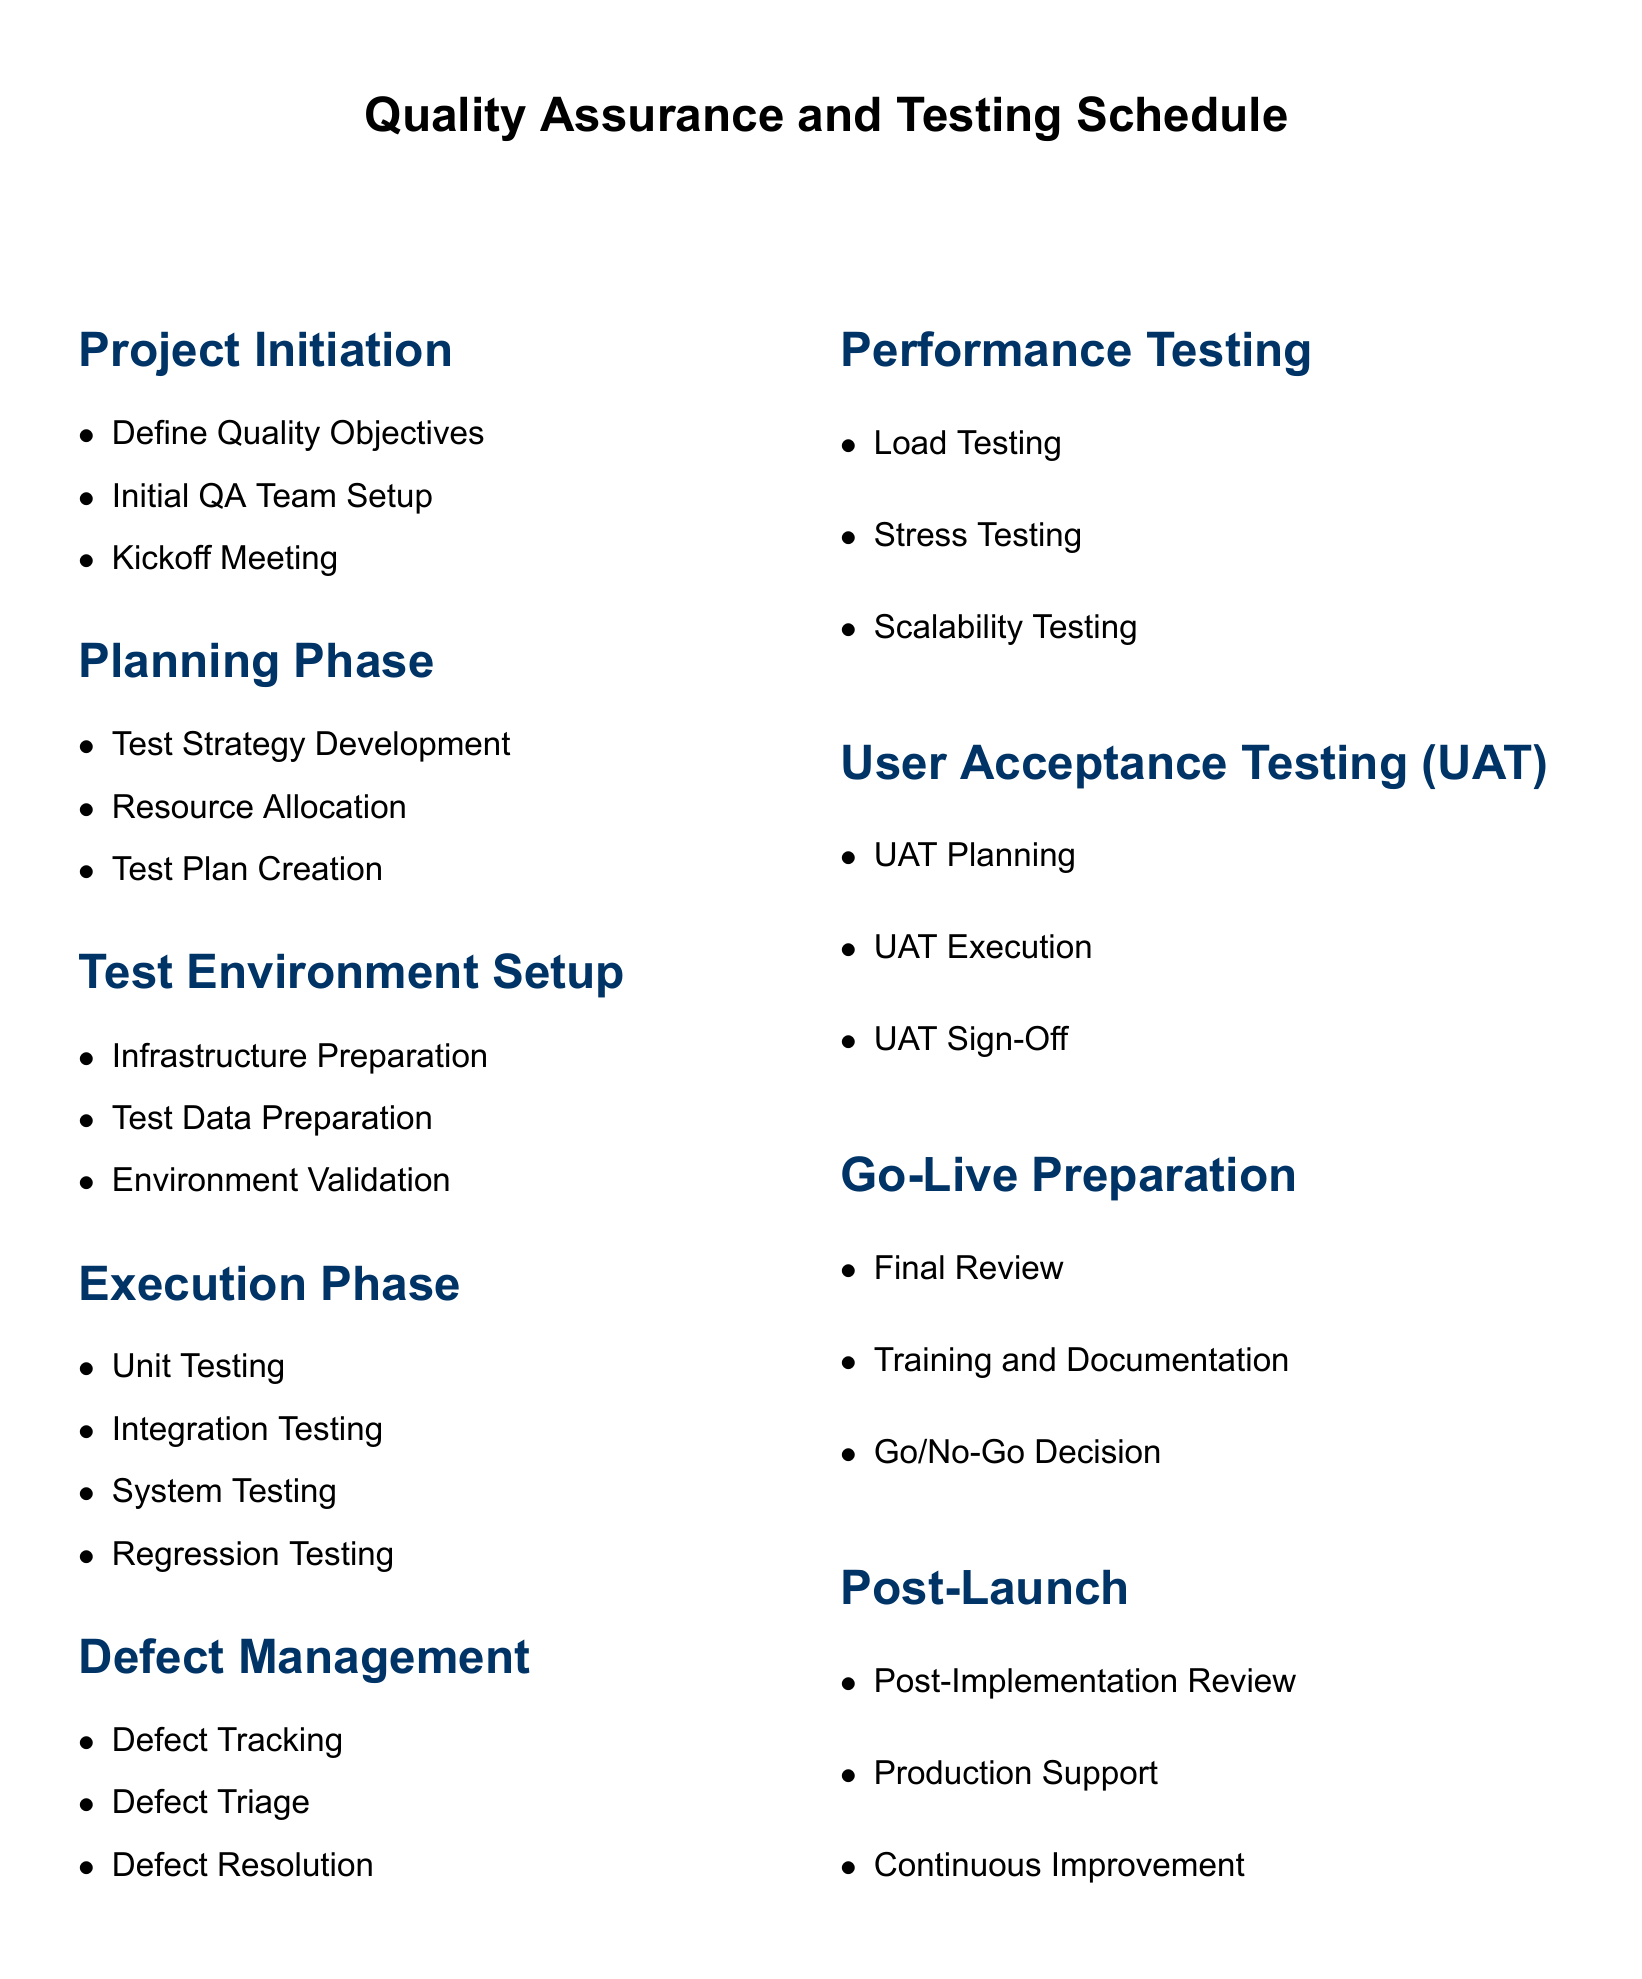What is the first item in the Project Initiation section? The first item listed under Project Initiation is "Define Quality Objectives."
Answer: Define Quality Objectives How many phases are listed in the document? The document lists seven phases, which are Project Initiation, Planning Phase, Test Environment Setup, Execution Phase, Defect Management, Performance Testing, User Acceptance Testing, Go-Live Preparation, and Post-Launch.
Answer: Seven What are the three main tasks in the Execution Phase? The tasks listed in the Execution Phase are Unit Testing, Integration Testing, System Testing, and Regression Testing, totaling four tasks.
Answer: Four What is the last item in the Post-Launch section? The last item mentioned in the Post-Launch section is "Continuous Improvement."
Answer: Continuous Improvement Which section includes the UAT Sign-Off? The "User Acceptance Testing (UAT)" section includes the UAT Sign-Off.
Answer: User Acceptance Testing (UAT) What is the purpose of the Go/No-Go Decision? The Go/No-Go Decision is part of the Go-Live Preparation phase, indicating readiness to proceed.
Answer: Indicate readiness to proceed Which phase is focused on readiness for deployment? The phase focused on readiness for deployment is "Go-Live Preparation."
Answer: Go-Live Preparation What type of testing is included under Performance Testing? The types of testing included under Performance Testing are Load Testing, Stress Testing, and Scalability Testing.
Answer: Load Testing, Stress Testing, Scalability Testing What is included in the Defect Management section? The Defect Management section includes Defect Tracking, Defect Triage, and Defect Resolution.
Answer: Defect Tracking, Defect Triage, Defect Resolution 